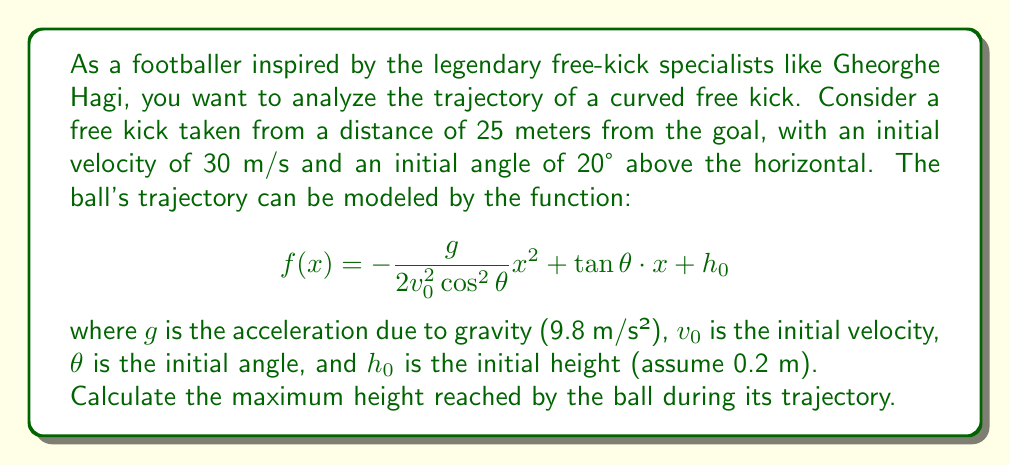What is the answer to this math problem? To find the maximum height of the ball's trajectory, we need to follow these steps:

1) First, let's substitute the given values into our function:
   $g = 9.8$ m/s²
   $v_0 = 30$ m/s
   $\theta = 20°$
   $h_0 = 0.2$ m

2) Our function becomes:
   $$f(x) = -\frac{9.8}{2(30^2)\cos^2(20°)}x^2 + \tan(20°) \cdot x + 0.2$$

3) Simplify:
   $$f(x) = -0.005934x^2 + 0.3640x + 0.2$$

4) To find the maximum height, we need to find the vertex of this parabola. The x-coordinate of the vertex is given by $x = -\frac{b}{2a}$, where $a$ and $b$ are the coefficients of $x^2$ and $x$ respectively.

5) Calculate x-coordinate of the vertex:
   $$x = -\frac{0.3640}{2(-0.005934)} = 30.68 \text{ m}$$

6) To find the maximum height, we substitute this x-value back into our original function:

   $$f(30.68) = -0.005934(30.68^2) + 0.3640(30.68) + 0.2$$
   
   $$= -5.59 + 11.17 + 0.2 = 5.78 \text{ m}$$

Therefore, the maximum height reached by the ball is approximately 5.78 meters.
Answer: The maximum height reached by the ball during its trajectory is approximately 5.78 meters. 